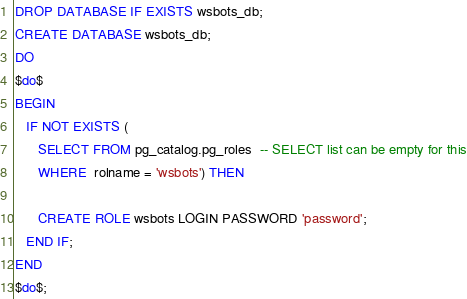Convert code to text. <code><loc_0><loc_0><loc_500><loc_500><_SQL_>DROP DATABASE IF EXISTS wsbots_db;
CREATE DATABASE wsbots_db;
DO
$do$
BEGIN
   IF NOT EXISTS (
      SELECT FROM pg_catalog.pg_roles  -- SELECT list can be empty for this
      WHERE  rolname = 'wsbots') THEN

      CREATE ROLE wsbots LOGIN PASSWORD 'password';
   END IF;
END
$do$;</code> 